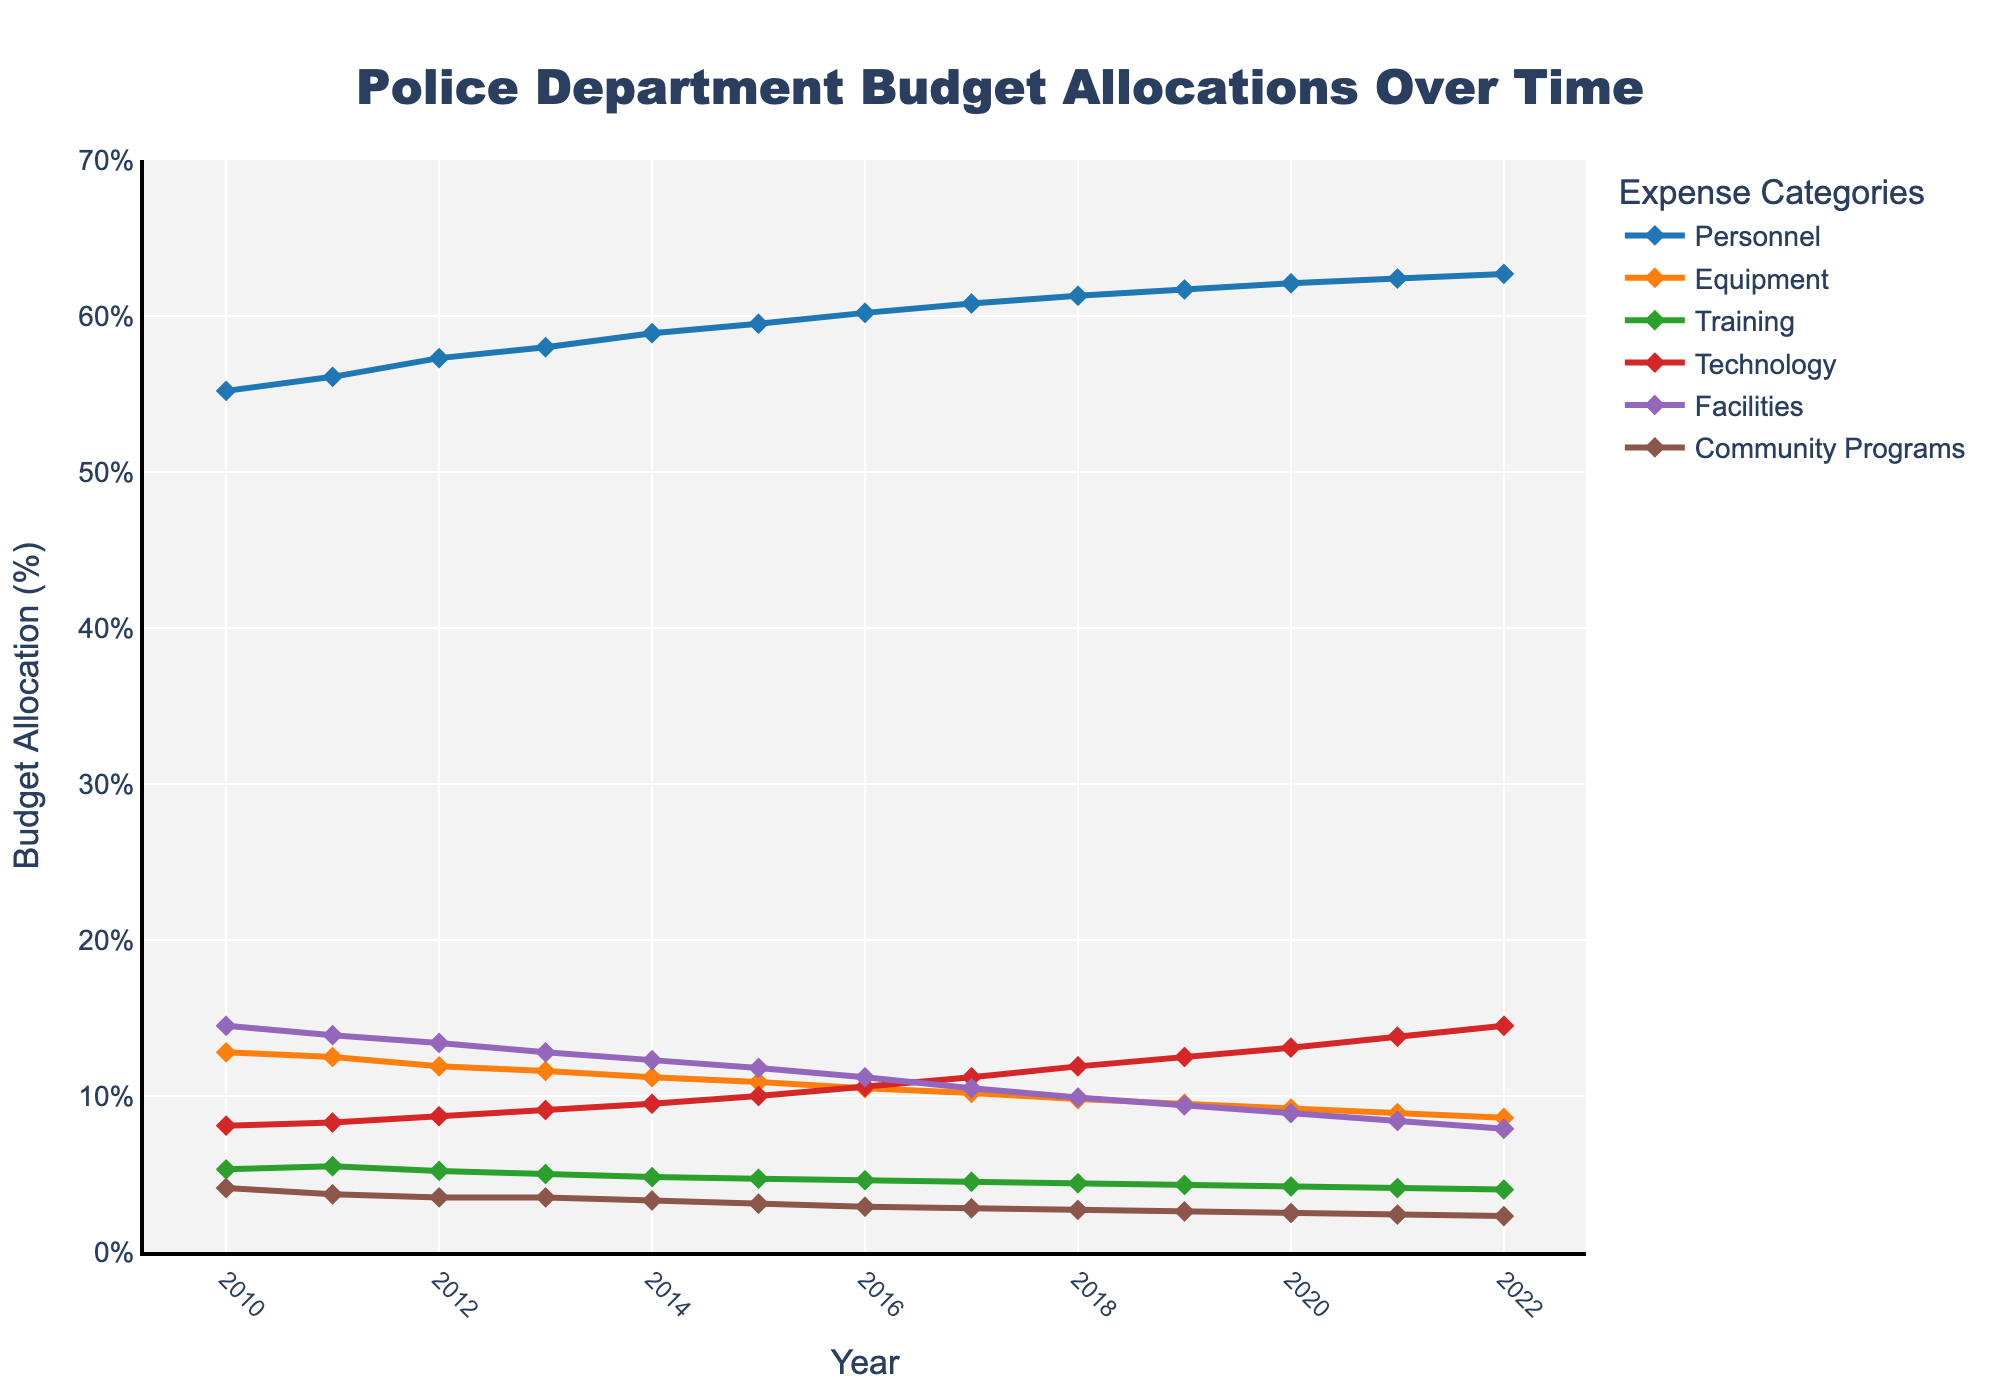What's the trend in Personnel budget allocation from 2010 to 2022? The figure shows a continuous increase in the Personnel budget allocation over the years. Starting at 55.2% in 2010 and rising to 62.7% in 2022, there is a noticeable upward trend.
Answer: Upward Which expense category saw the most significant decrease between 2010 and 2022? By examining the length of the lines for each category, Community Programs saw the most significant decrease, starting from 4.1% in 2010 to 2.3% in 2022.
Answer: Community Programs In which years did the Technology budget allocation surpass the Equipment budget allocation? To find this, we compare the heights of the Technology and Equipment lines for each year. We see that from 2015 onward, Technology's percentage consistently surpassed Equipment's percentage.
Answer: 2015 to 2022 What's the average budget allocation for Training from 2010 to 2022? Calculate the sum of the Training allocations from 2010 to 2022, which is (5.3 + 5.5 + 5.2 + 5.0 + 4.8 + 4.7 + 4.6 + 4.5 + 4.4 + 4.3 + 4.2 + 4.1 + 4.0), which equals 61.6. Then divide the sum by the number of years (13).
Answer: 4.7% What's the maximum allocation percentage for Facilities, and in which year did it occur? Look at the peak point of the Facilities line, which reaches its highest in 2010 at 14.5%.
Answer: 14.5% in 2010 Compare the rate of decline for Equipment and Facilities from 2010 to 2022. Which one declined faster? Determine the difference between the initial and final values for Equipment (12.8 - 8.6 = 3.9) and Facilities (14.5 - 7.9 = 6.6). The greater difference indicates that Facilities experienced a faster rate of decline.
Answer: Facilities What's the most noticeable trend in Technology budget allocation? Observing the entire line for Technology, there is a continuous upward trend, starting from 8.1% in 2010 and increasing to 14.5% in 2022.
Answer: Continuous upward What's the combined budget allocation percentage for Personnel and Technology in 2022? Add the allocation percentages for Personnel and Technology in 2022, which are 62.7% and 14.5%, respectively.
Answer: 77.2% In the year 2020, how much higher was the Personnel budget compared to the Equipment budget? Subtract the Equipment budget (9.2%) from the Personnel budget (62.1%) in 2020.
Answer: 52.9% During which year did Community Programs have the same budget allocation as Technology? Analyze the points where the lines intersect. In 2013, Community Programs (3.5%) had the same allocation as Technology (3.5%).
Answer: 2013 